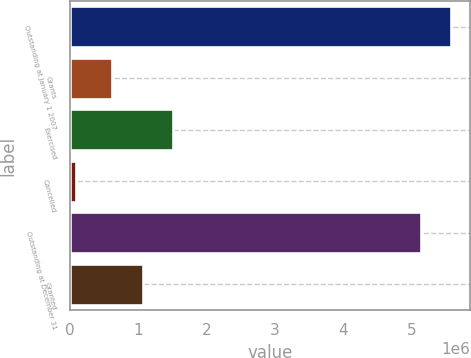Convert chart. <chart><loc_0><loc_0><loc_500><loc_500><bar_chart><fcel>Outstanding at January 1 2007<fcel>Grants<fcel>Exercised<fcel>Cancelled<fcel>Outstanding at December 31<fcel>Granted<nl><fcel>5.57854e+06<fcel>616450<fcel>1.51459e+06<fcel>88100<fcel>5.12946e+06<fcel>1.06552e+06<nl></chart> 